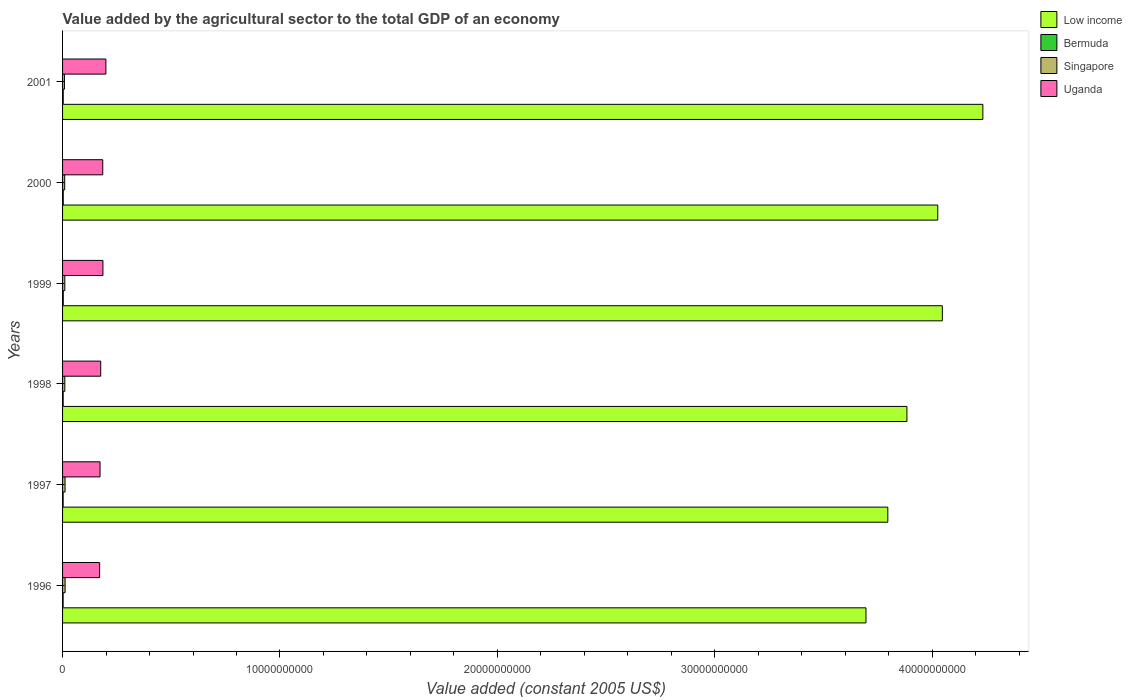Are the number of bars per tick equal to the number of legend labels?
Offer a very short reply. Yes. Are the number of bars on each tick of the Y-axis equal?
Your answer should be compact. Yes. In how many cases, is the number of bars for a given year not equal to the number of legend labels?
Make the answer very short. 0. What is the value added by the agricultural sector in Low income in 1996?
Your response must be concise. 3.70e+1. Across all years, what is the maximum value added by the agricultural sector in Uganda?
Ensure brevity in your answer.  1.99e+09. Across all years, what is the minimum value added by the agricultural sector in Uganda?
Offer a terse response. 1.71e+09. In which year was the value added by the agricultural sector in Singapore minimum?
Your response must be concise. 2001. What is the total value added by the agricultural sector in Bermuda in the graph?
Provide a short and direct response. 1.75e+08. What is the difference between the value added by the agricultural sector in Singapore in 1998 and that in 2000?
Your response must be concise. 5.67e+06. What is the difference between the value added by the agricultural sector in Singapore in 2000 and the value added by the agricultural sector in Low income in 2001?
Offer a very short reply. -4.22e+1. What is the average value added by the agricultural sector in Bermuda per year?
Ensure brevity in your answer.  2.92e+07. In the year 1998, what is the difference between the value added by the agricultural sector in Low income and value added by the agricultural sector in Bermuda?
Make the answer very short. 3.88e+1. What is the ratio of the value added by the agricultural sector in Uganda in 1997 to that in 1998?
Give a very brief answer. 0.98. What is the difference between the highest and the second highest value added by the agricultural sector in Low income?
Keep it short and to the point. 1.86e+09. What is the difference between the highest and the lowest value added by the agricultural sector in Uganda?
Your answer should be very brief. 2.88e+08. Is it the case that in every year, the sum of the value added by the agricultural sector in Singapore and value added by the agricultural sector in Uganda is greater than the sum of value added by the agricultural sector in Low income and value added by the agricultural sector in Bermuda?
Make the answer very short. Yes. What does the 1st bar from the top in 1996 represents?
Ensure brevity in your answer.  Uganda. What does the 3rd bar from the bottom in 1996 represents?
Keep it short and to the point. Singapore. Is it the case that in every year, the sum of the value added by the agricultural sector in Uganda and value added by the agricultural sector in Low income is greater than the value added by the agricultural sector in Singapore?
Provide a succinct answer. Yes. How many bars are there?
Provide a short and direct response. 24. How many years are there in the graph?
Make the answer very short. 6. Does the graph contain any zero values?
Ensure brevity in your answer.  No. How many legend labels are there?
Your answer should be very brief. 4. How are the legend labels stacked?
Provide a short and direct response. Vertical. What is the title of the graph?
Ensure brevity in your answer.  Value added by the agricultural sector to the total GDP of an economy. Does "Tuvalu" appear as one of the legend labels in the graph?
Your answer should be compact. No. What is the label or title of the X-axis?
Keep it short and to the point. Value added (constant 2005 US$). What is the Value added (constant 2005 US$) of Low income in 1996?
Your response must be concise. 3.70e+1. What is the Value added (constant 2005 US$) in Bermuda in 1996?
Your response must be concise. 2.56e+07. What is the Value added (constant 2005 US$) in Singapore in 1996?
Your response must be concise. 1.16e+08. What is the Value added (constant 2005 US$) in Uganda in 1996?
Offer a terse response. 1.71e+09. What is the Value added (constant 2005 US$) of Low income in 1997?
Offer a terse response. 3.80e+1. What is the Value added (constant 2005 US$) in Bermuda in 1997?
Your answer should be compact. 2.68e+07. What is the Value added (constant 2005 US$) in Singapore in 1997?
Make the answer very short. 1.14e+08. What is the Value added (constant 2005 US$) in Uganda in 1997?
Offer a very short reply. 1.72e+09. What is the Value added (constant 2005 US$) in Low income in 1998?
Provide a succinct answer. 3.88e+1. What is the Value added (constant 2005 US$) in Bermuda in 1998?
Your answer should be compact. 2.78e+07. What is the Value added (constant 2005 US$) of Singapore in 1998?
Offer a terse response. 1.04e+08. What is the Value added (constant 2005 US$) in Uganda in 1998?
Offer a very short reply. 1.75e+09. What is the Value added (constant 2005 US$) of Low income in 1999?
Provide a short and direct response. 4.05e+1. What is the Value added (constant 2005 US$) in Bermuda in 1999?
Ensure brevity in your answer.  3.24e+07. What is the Value added (constant 2005 US$) of Singapore in 1999?
Ensure brevity in your answer.  1.04e+08. What is the Value added (constant 2005 US$) of Uganda in 1999?
Your answer should be very brief. 1.86e+09. What is the Value added (constant 2005 US$) of Low income in 2000?
Make the answer very short. 4.03e+1. What is the Value added (constant 2005 US$) in Bermuda in 2000?
Offer a very short reply. 3.15e+07. What is the Value added (constant 2005 US$) in Singapore in 2000?
Ensure brevity in your answer.  9.86e+07. What is the Value added (constant 2005 US$) of Uganda in 2000?
Offer a very short reply. 1.85e+09. What is the Value added (constant 2005 US$) in Low income in 2001?
Offer a terse response. 4.23e+1. What is the Value added (constant 2005 US$) in Bermuda in 2001?
Provide a short and direct response. 3.10e+07. What is the Value added (constant 2005 US$) of Singapore in 2001?
Provide a short and direct response. 8.63e+07. What is the Value added (constant 2005 US$) in Uganda in 2001?
Provide a succinct answer. 1.99e+09. Across all years, what is the maximum Value added (constant 2005 US$) in Low income?
Provide a succinct answer. 4.23e+1. Across all years, what is the maximum Value added (constant 2005 US$) in Bermuda?
Offer a terse response. 3.24e+07. Across all years, what is the maximum Value added (constant 2005 US$) of Singapore?
Your response must be concise. 1.16e+08. Across all years, what is the maximum Value added (constant 2005 US$) in Uganda?
Provide a short and direct response. 1.99e+09. Across all years, what is the minimum Value added (constant 2005 US$) of Low income?
Provide a succinct answer. 3.70e+1. Across all years, what is the minimum Value added (constant 2005 US$) of Bermuda?
Give a very brief answer. 2.56e+07. Across all years, what is the minimum Value added (constant 2005 US$) of Singapore?
Offer a very short reply. 8.63e+07. Across all years, what is the minimum Value added (constant 2005 US$) in Uganda?
Offer a terse response. 1.71e+09. What is the total Value added (constant 2005 US$) in Low income in the graph?
Provide a succinct answer. 2.37e+11. What is the total Value added (constant 2005 US$) of Bermuda in the graph?
Your response must be concise. 1.75e+08. What is the total Value added (constant 2005 US$) in Singapore in the graph?
Ensure brevity in your answer.  6.23e+08. What is the total Value added (constant 2005 US$) in Uganda in the graph?
Make the answer very short. 1.09e+1. What is the difference between the Value added (constant 2005 US$) in Low income in 1996 and that in 1997?
Make the answer very short. -1.00e+09. What is the difference between the Value added (constant 2005 US$) of Bermuda in 1996 and that in 1997?
Your response must be concise. -1.18e+06. What is the difference between the Value added (constant 2005 US$) in Singapore in 1996 and that in 1997?
Make the answer very short. 1.75e+06. What is the difference between the Value added (constant 2005 US$) in Uganda in 1996 and that in 1997?
Make the answer very short. -1.86e+07. What is the difference between the Value added (constant 2005 US$) in Low income in 1996 and that in 1998?
Ensure brevity in your answer.  -1.88e+09. What is the difference between the Value added (constant 2005 US$) of Bermuda in 1996 and that in 1998?
Make the answer very short. -2.22e+06. What is the difference between the Value added (constant 2005 US$) of Singapore in 1996 and that in 1998?
Keep it short and to the point. 1.16e+07. What is the difference between the Value added (constant 2005 US$) of Uganda in 1996 and that in 1998?
Provide a succinct answer. -4.91e+07. What is the difference between the Value added (constant 2005 US$) in Low income in 1996 and that in 1999?
Ensure brevity in your answer.  -3.51e+09. What is the difference between the Value added (constant 2005 US$) of Bermuda in 1996 and that in 1999?
Provide a short and direct response. -6.76e+06. What is the difference between the Value added (constant 2005 US$) in Singapore in 1996 and that in 1999?
Provide a short and direct response. 1.23e+07. What is the difference between the Value added (constant 2005 US$) in Uganda in 1996 and that in 1999?
Your answer should be compact. -1.51e+08. What is the difference between the Value added (constant 2005 US$) in Low income in 1996 and that in 2000?
Provide a short and direct response. -3.30e+09. What is the difference between the Value added (constant 2005 US$) in Bermuda in 1996 and that in 2000?
Your response must be concise. -5.92e+06. What is the difference between the Value added (constant 2005 US$) of Singapore in 1996 and that in 2000?
Your response must be concise. 1.73e+07. What is the difference between the Value added (constant 2005 US$) of Uganda in 1996 and that in 2000?
Offer a terse response. -1.43e+08. What is the difference between the Value added (constant 2005 US$) of Low income in 1996 and that in 2001?
Offer a terse response. -5.38e+09. What is the difference between the Value added (constant 2005 US$) in Bermuda in 1996 and that in 2001?
Your answer should be very brief. -5.35e+06. What is the difference between the Value added (constant 2005 US$) in Singapore in 1996 and that in 2001?
Your answer should be compact. 2.97e+07. What is the difference between the Value added (constant 2005 US$) in Uganda in 1996 and that in 2001?
Your answer should be very brief. -2.88e+08. What is the difference between the Value added (constant 2005 US$) in Low income in 1997 and that in 1998?
Make the answer very short. -8.79e+08. What is the difference between the Value added (constant 2005 US$) in Bermuda in 1997 and that in 1998?
Ensure brevity in your answer.  -1.04e+06. What is the difference between the Value added (constant 2005 US$) in Singapore in 1997 and that in 1998?
Keep it short and to the point. 9.89e+06. What is the difference between the Value added (constant 2005 US$) in Uganda in 1997 and that in 1998?
Offer a terse response. -3.05e+07. What is the difference between the Value added (constant 2005 US$) in Low income in 1997 and that in 1999?
Provide a short and direct response. -2.51e+09. What is the difference between the Value added (constant 2005 US$) of Bermuda in 1997 and that in 1999?
Offer a terse response. -5.58e+06. What is the difference between the Value added (constant 2005 US$) in Singapore in 1997 and that in 1999?
Ensure brevity in your answer.  1.06e+07. What is the difference between the Value added (constant 2005 US$) in Uganda in 1997 and that in 1999?
Ensure brevity in your answer.  -1.33e+08. What is the difference between the Value added (constant 2005 US$) in Low income in 1997 and that in 2000?
Offer a very short reply. -2.30e+09. What is the difference between the Value added (constant 2005 US$) of Bermuda in 1997 and that in 2000?
Make the answer very short. -4.74e+06. What is the difference between the Value added (constant 2005 US$) of Singapore in 1997 and that in 2000?
Provide a succinct answer. 1.56e+07. What is the difference between the Value added (constant 2005 US$) of Uganda in 1997 and that in 2000?
Make the answer very short. -1.25e+08. What is the difference between the Value added (constant 2005 US$) in Low income in 1997 and that in 2001?
Ensure brevity in your answer.  -4.37e+09. What is the difference between the Value added (constant 2005 US$) of Bermuda in 1997 and that in 2001?
Your answer should be compact. -4.17e+06. What is the difference between the Value added (constant 2005 US$) of Singapore in 1997 and that in 2001?
Provide a short and direct response. 2.79e+07. What is the difference between the Value added (constant 2005 US$) of Uganda in 1997 and that in 2001?
Give a very brief answer. -2.70e+08. What is the difference between the Value added (constant 2005 US$) in Low income in 1998 and that in 1999?
Your answer should be compact. -1.63e+09. What is the difference between the Value added (constant 2005 US$) of Bermuda in 1998 and that in 1999?
Your response must be concise. -4.54e+06. What is the difference between the Value added (constant 2005 US$) of Singapore in 1998 and that in 1999?
Your answer should be very brief. 6.63e+05. What is the difference between the Value added (constant 2005 US$) in Uganda in 1998 and that in 1999?
Offer a terse response. -1.02e+08. What is the difference between the Value added (constant 2005 US$) of Low income in 1998 and that in 2000?
Your answer should be very brief. -1.42e+09. What is the difference between the Value added (constant 2005 US$) of Bermuda in 1998 and that in 2000?
Provide a succinct answer. -3.70e+06. What is the difference between the Value added (constant 2005 US$) in Singapore in 1998 and that in 2000?
Ensure brevity in your answer.  5.67e+06. What is the difference between the Value added (constant 2005 US$) in Uganda in 1998 and that in 2000?
Provide a succinct answer. -9.40e+07. What is the difference between the Value added (constant 2005 US$) in Low income in 1998 and that in 2001?
Your answer should be compact. -3.49e+09. What is the difference between the Value added (constant 2005 US$) of Bermuda in 1998 and that in 2001?
Keep it short and to the point. -3.12e+06. What is the difference between the Value added (constant 2005 US$) in Singapore in 1998 and that in 2001?
Your response must be concise. 1.80e+07. What is the difference between the Value added (constant 2005 US$) in Uganda in 1998 and that in 2001?
Provide a short and direct response. -2.39e+08. What is the difference between the Value added (constant 2005 US$) in Low income in 1999 and that in 2000?
Make the answer very short. 2.11e+08. What is the difference between the Value added (constant 2005 US$) of Bermuda in 1999 and that in 2000?
Offer a very short reply. 8.38e+05. What is the difference between the Value added (constant 2005 US$) of Singapore in 1999 and that in 2000?
Give a very brief answer. 5.00e+06. What is the difference between the Value added (constant 2005 US$) of Uganda in 1999 and that in 2000?
Provide a short and direct response. 8.14e+06. What is the difference between the Value added (constant 2005 US$) in Low income in 1999 and that in 2001?
Your answer should be compact. -1.86e+09. What is the difference between the Value added (constant 2005 US$) in Bermuda in 1999 and that in 2001?
Your answer should be compact. 1.42e+06. What is the difference between the Value added (constant 2005 US$) in Singapore in 1999 and that in 2001?
Your answer should be compact. 1.74e+07. What is the difference between the Value added (constant 2005 US$) in Uganda in 1999 and that in 2001?
Your response must be concise. -1.37e+08. What is the difference between the Value added (constant 2005 US$) in Low income in 2000 and that in 2001?
Make the answer very short. -2.07e+09. What is the difference between the Value added (constant 2005 US$) in Bermuda in 2000 and that in 2001?
Make the answer very short. 5.77e+05. What is the difference between the Value added (constant 2005 US$) in Singapore in 2000 and that in 2001?
Your response must be concise. 1.24e+07. What is the difference between the Value added (constant 2005 US$) in Uganda in 2000 and that in 2001?
Give a very brief answer. -1.45e+08. What is the difference between the Value added (constant 2005 US$) in Low income in 1996 and the Value added (constant 2005 US$) in Bermuda in 1997?
Ensure brevity in your answer.  3.69e+1. What is the difference between the Value added (constant 2005 US$) in Low income in 1996 and the Value added (constant 2005 US$) in Singapore in 1997?
Offer a terse response. 3.68e+1. What is the difference between the Value added (constant 2005 US$) in Low income in 1996 and the Value added (constant 2005 US$) in Uganda in 1997?
Offer a terse response. 3.52e+1. What is the difference between the Value added (constant 2005 US$) in Bermuda in 1996 and the Value added (constant 2005 US$) in Singapore in 1997?
Offer a terse response. -8.86e+07. What is the difference between the Value added (constant 2005 US$) of Bermuda in 1996 and the Value added (constant 2005 US$) of Uganda in 1997?
Your answer should be very brief. -1.70e+09. What is the difference between the Value added (constant 2005 US$) in Singapore in 1996 and the Value added (constant 2005 US$) in Uganda in 1997?
Provide a short and direct response. -1.61e+09. What is the difference between the Value added (constant 2005 US$) in Low income in 1996 and the Value added (constant 2005 US$) in Bermuda in 1998?
Give a very brief answer. 3.69e+1. What is the difference between the Value added (constant 2005 US$) of Low income in 1996 and the Value added (constant 2005 US$) of Singapore in 1998?
Your response must be concise. 3.68e+1. What is the difference between the Value added (constant 2005 US$) in Low income in 1996 and the Value added (constant 2005 US$) in Uganda in 1998?
Give a very brief answer. 3.52e+1. What is the difference between the Value added (constant 2005 US$) in Bermuda in 1996 and the Value added (constant 2005 US$) in Singapore in 1998?
Keep it short and to the point. -7.87e+07. What is the difference between the Value added (constant 2005 US$) of Bermuda in 1996 and the Value added (constant 2005 US$) of Uganda in 1998?
Offer a terse response. -1.73e+09. What is the difference between the Value added (constant 2005 US$) of Singapore in 1996 and the Value added (constant 2005 US$) of Uganda in 1998?
Give a very brief answer. -1.64e+09. What is the difference between the Value added (constant 2005 US$) of Low income in 1996 and the Value added (constant 2005 US$) of Bermuda in 1999?
Keep it short and to the point. 3.69e+1. What is the difference between the Value added (constant 2005 US$) of Low income in 1996 and the Value added (constant 2005 US$) of Singapore in 1999?
Make the answer very short. 3.68e+1. What is the difference between the Value added (constant 2005 US$) of Low income in 1996 and the Value added (constant 2005 US$) of Uganda in 1999?
Ensure brevity in your answer.  3.51e+1. What is the difference between the Value added (constant 2005 US$) of Bermuda in 1996 and the Value added (constant 2005 US$) of Singapore in 1999?
Provide a succinct answer. -7.80e+07. What is the difference between the Value added (constant 2005 US$) of Bermuda in 1996 and the Value added (constant 2005 US$) of Uganda in 1999?
Your answer should be very brief. -1.83e+09. What is the difference between the Value added (constant 2005 US$) in Singapore in 1996 and the Value added (constant 2005 US$) in Uganda in 1999?
Provide a succinct answer. -1.74e+09. What is the difference between the Value added (constant 2005 US$) in Low income in 1996 and the Value added (constant 2005 US$) in Bermuda in 2000?
Ensure brevity in your answer.  3.69e+1. What is the difference between the Value added (constant 2005 US$) of Low income in 1996 and the Value added (constant 2005 US$) of Singapore in 2000?
Make the answer very short. 3.69e+1. What is the difference between the Value added (constant 2005 US$) of Low income in 1996 and the Value added (constant 2005 US$) of Uganda in 2000?
Your response must be concise. 3.51e+1. What is the difference between the Value added (constant 2005 US$) of Bermuda in 1996 and the Value added (constant 2005 US$) of Singapore in 2000?
Ensure brevity in your answer.  -7.30e+07. What is the difference between the Value added (constant 2005 US$) in Bermuda in 1996 and the Value added (constant 2005 US$) in Uganda in 2000?
Your response must be concise. -1.82e+09. What is the difference between the Value added (constant 2005 US$) in Singapore in 1996 and the Value added (constant 2005 US$) in Uganda in 2000?
Your response must be concise. -1.73e+09. What is the difference between the Value added (constant 2005 US$) in Low income in 1996 and the Value added (constant 2005 US$) in Bermuda in 2001?
Give a very brief answer. 3.69e+1. What is the difference between the Value added (constant 2005 US$) of Low income in 1996 and the Value added (constant 2005 US$) of Singapore in 2001?
Give a very brief answer. 3.69e+1. What is the difference between the Value added (constant 2005 US$) in Low income in 1996 and the Value added (constant 2005 US$) in Uganda in 2001?
Your response must be concise. 3.50e+1. What is the difference between the Value added (constant 2005 US$) in Bermuda in 1996 and the Value added (constant 2005 US$) in Singapore in 2001?
Make the answer very short. -6.07e+07. What is the difference between the Value added (constant 2005 US$) in Bermuda in 1996 and the Value added (constant 2005 US$) in Uganda in 2001?
Provide a short and direct response. -1.97e+09. What is the difference between the Value added (constant 2005 US$) of Singapore in 1996 and the Value added (constant 2005 US$) of Uganda in 2001?
Give a very brief answer. -1.88e+09. What is the difference between the Value added (constant 2005 US$) in Low income in 1997 and the Value added (constant 2005 US$) in Bermuda in 1998?
Your response must be concise. 3.79e+1. What is the difference between the Value added (constant 2005 US$) in Low income in 1997 and the Value added (constant 2005 US$) in Singapore in 1998?
Offer a terse response. 3.79e+1. What is the difference between the Value added (constant 2005 US$) in Low income in 1997 and the Value added (constant 2005 US$) in Uganda in 1998?
Provide a succinct answer. 3.62e+1. What is the difference between the Value added (constant 2005 US$) in Bermuda in 1997 and the Value added (constant 2005 US$) in Singapore in 1998?
Your answer should be compact. -7.75e+07. What is the difference between the Value added (constant 2005 US$) of Bermuda in 1997 and the Value added (constant 2005 US$) of Uganda in 1998?
Keep it short and to the point. -1.73e+09. What is the difference between the Value added (constant 2005 US$) of Singapore in 1997 and the Value added (constant 2005 US$) of Uganda in 1998?
Give a very brief answer. -1.64e+09. What is the difference between the Value added (constant 2005 US$) of Low income in 1997 and the Value added (constant 2005 US$) of Bermuda in 1999?
Offer a very short reply. 3.79e+1. What is the difference between the Value added (constant 2005 US$) of Low income in 1997 and the Value added (constant 2005 US$) of Singapore in 1999?
Your answer should be compact. 3.79e+1. What is the difference between the Value added (constant 2005 US$) of Low income in 1997 and the Value added (constant 2005 US$) of Uganda in 1999?
Offer a terse response. 3.61e+1. What is the difference between the Value added (constant 2005 US$) of Bermuda in 1997 and the Value added (constant 2005 US$) of Singapore in 1999?
Your response must be concise. -7.68e+07. What is the difference between the Value added (constant 2005 US$) of Bermuda in 1997 and the Value added (constant 2005 US$) of Uganda in 1999?
Offer a terse response. -1.83e+09. What is the difference between the Value added (constant 2005 US$) in Singapore in 1997 and the Value added (constant 2005 US$) in Uganda in 1999?
Make the answer very short. -1.74e+09. What is the difference between the Value added (constant 2005 US$) of Low income in 1997 and the Value added (constant 2005 US$) of Bermuda in 2000?
Provide a succinct answer. 3.79e+1. What is the difference between the Value added (constant 2005 US$) in Low income in 1997 and the Value added (constant 2005 US$) in Singapore in 2000?
Keep it short and to the point. 3.79e+1. What is the difference between the Value added (constant 2005 US$) of Low income in 1997 and the Value added (constant 2005 US$) of Uganda in 2000?
Offer a very short reply. 3.61e+1. What is the difference between the Value added (constant 2005 US$) of Bermuda in 1997 and the Value added (constant 2005 US$) of Singapore in 2000?
Offer a terse response. -7.18e+07. What is the difference between the Value added (constant 2005 US$) in Bermuda in 1997 and the Value added (constant 2005 US$) in Uganda in 2000?
Ensure brevity in your answer.  -1.82e+09. What is the difference between the Value added (constant 2005 US$) in Singapore in 1997 and the Value added (constant 2005 US$) in Uganda in 2000?
Your answer should be compact. -1.73e+09. What is the difference between the Value added (constant 2005 US$) of Low income in 1997 and the Value added (constant 2005 US$) of Bermuda in 2001?
Your answer should be very brief. 3.79e+1. What is the difference between the Value added (constant 2005 US$) in Low income in 1997 and the Value added (constant 2005 US$) in Singapore in 2001?
Provide a short and direct response. 3.79e+1. What is the difference between the Value added (constant 2005 US$) in Low income in 1997 and the Value added (constant 2005 US$) in Uganda in 2001?
Offer a very short reply. 3.60e+1. What is the difference between the Value added (constant 2005 US$) of Bermuda in 1997 and the Value added (constant 2005 US$) of Singapore in 2001?
Offer a very short reply. -5.95e+07. What is the difference between the Value added (constant 2005 US$) of Bermuda in 1997 and the Value added (constant 2005 US$) of Uganda in 2001?
Keep it short and to the point. -1.97e+09. What is the difference between the Value added (constant 2005 US$) of Singapore in 1997 and the Value added (constant 2005 US$) of Uganda in 2001?
Provide a succinct answer. -1.88e+09. What is the difference between the Value added (constant 2005 US$) of Low income in 1998 and the Value added (constant 2005 US$) of Bermuda in 1999?
Keep it short and to the point. 3.88e+1. What is the difference between the Value added (constant 2005 US$) in Low income in 1998 and the Value added (constant 2005 US$) in Singapore in 1999?
Give a very brief answer. 3.87e+1. What is the difference between the Value added (constant 2005 US$) in Low income in 1998 and the Value added (constant 2005 US$) in Uganda in 1999?
Make the answer very short. 3.70e+1. What is the difference between the Value added (constant 2005 US$) in Bermuda in 1998 and the Value added (constant 2005 US$) in Singapore in 1999?
Provide a short and direct response. -7.58e+07. What is the difference between the Value added (constant 2005 US$) of Bermuda in 1998 and the Value added (constant 2005 US$) of Uganda in 1999?
Provide a short and direct response. -1.83e+09. What is the difference between the Value added (constant 2005 US$) of Singapore in 1998 and the Value added (constant 2005 US$) of Uganda in 1999?
Offer a very short reply. -1.75e+09. What is the difference between the Value added (constant 2005 US$) in Low income in 1998 and the Value added (constant 2005 US$) in Bermuda in 2000?
Make the answer very short. 3.88e+1. What is the difference between the Value added (constant 2005 US$) of Low income in 1998 and the Value added (constant 2005 US$) of Singapore in 2000?
Offer a terse response. 3.87e+1. What is the difference between the Value added (constant 2005 US$) in Low income in 1998 and the Value added (constant 2005 US$) in Uganda in 2000?
Give a very brief answer. 3.70e+1. What is the difference between the Value added (constant 2005 US$) of Bermuda in 1998 and the Value added (constant 2005 US$) of Singapore in 2000?
Keep it short and to the point. -7.08e+07. What is the difference between the Value added (constant 2005 US$) in Bermuda in 1998 and the Value added (constant 2005 US$) in Uganda in 2000?
Provide a succinct answer. -1.82e+09. What is the difference between the Value added (constant 2005 US$) of Singapore in 1998 and the Value added (constant 2005 US$) of Uganda in 2000?
Ensure brevity in your answer.  -1.74e+09. What is the difference between the Value added (constant 2005 US$) in Low income in 1998 and the Value added (constant 2005 US$) in Bermuda in 2001?
Make the answer very short. 3.88e+1. What is the difference between the Value added (constant 2005 US$) in Low income in 1998 and the Value added (constant 2005 US$) in Singapore in 2001?
Offer a very short reply. 3.87e+1. What is the difference between the Value added (constant 2005 US$) in Low income in 1998 and the Value added (constant 2005 US$) in Uganda in 2001?
Give a very brief answer. 3.68e+1. What is the difference between the Value added (constant 2005 US$) of Bermuda in 1998 and the Value added (constant 2005 US$) of Singapore in 2001?
Your answer should be very brief. -5.84e+07. What is the difference between the Value added (constant 2005 US$) in Bermuda in 1998 and the Value added (constant 2005 US$) in Uganda in 2001?
Provide a succinct answer. -1.97e+09. What is the difference between the Value added (constant 2005 US$) of Singapore in 1998 and the Value added (constant 2005 US$) of Uganda in 2001?
Provide a short and direct response. -1.89e+09. What is the difference between the Value added (constant 2005 US$) in Low income in 1999 and the Value added (constant 2005 US$) in Bermuda in 2000?
Your response must be concise. 4.04e+1. What is the difference between the Value added (constant 2005 US$) in Low income in 1999 and the Value added (constant 2005 US$) in Singapore in 2000?
Provide a succinct answer. 4.04e+1. What is the difference between the Value added (constant 2005 US$) in Low income in 1999 and the Value added (constant 2005 US$) in Uganda in 2000?
Ensure brevity in your answer.  3.86e+1. What is the difference between the Value added (constant 2005 US$) in Bermuda in 1999 and the Value added (constant 2005 US$) in Singapore in 2000?
Give a very brief answer. -6.63e+07. What is the difference between the Value added (constant 2005 US$) in Bermuda in 1999 and the Value added (constant 2005 US$) in Uganda in 2000?
Offer a terse response. -1.82e+09. What is the difference between the Value added (constant 2005 US$) in Singapore in 1999 and the Value added (constant 2005 US$) in Uganda in 2000?
Your answer should be very brief. -1.74e+09. What is the difference between the Value added (constant 2005 US$) of Low income in 1999 and the Value added (constant 2005 US$) of Bermuda in 2001?
Provide a succinct answer. 4.04e+1. What is the difference between the Value added (constant 2005 US$) of Low income in 1999 and the Value added (constant 2005 US$) of Singapore in 2001?
Keep it short and to the point. 4.04e+1. What is the difference between the Value added (constant 2005 US$) in Low income in 1999 and the Value added (constant 2005 US$) in Uganda in 2001?
Offer a very short reply. 3.85e+1. What is the difference between the Value added (constant 2005 US$) in Bermuda in 1999 and the Value added (constant 2005 US$) in Singapore in 2001?
Your response must be concise. -5.39e+07. What is the difference between the Value added (constant 2005 US$) in Bermuda in 1999 and the Value added (constant 2005 US$) in Uganda in 2001?
Make the answer very short. -1.96e+09. What is the difference between the Value added (constant 2005 US$) of Singapore in 1999 and the Value added (constant 2005 US$) of Uganda in 2001?
Offer a terse response. -1.89e+09. What is the difference between the Value added (constant 2005 US$) of Low income in 2000 and the Value added (constant 2005 US$) of Bermuda in 2001?
Ensure brevity in your answer.  4.02e+1. What is the difference between the Value added (constant 2005 US$) in Low income in 2000 and the Value added (constant 2005 US$) in Singapore in 2001?
Provide a short and direct response. 4.02e+1. What is the difference between the Value added (constant 2005 US$) of Low income in 2000 and the Value added (constant 2005 US$) of Uganda in 2001?
Give a very brief answer. 3.83e+1. What is the difference between the Value added (constant 2005 US$) of Bermuda in 2000 and the Value added (constant 2005 US$) of Singapore in 2001?
Your answer should be compact. -5.47e+07. What is the difference between the Value added (constant 2005 US$) of Bermuda in 2000 and the Value added (constant 2005 US$) of Uganda in 2001?
Make the answer very short. -1.96e+09. What is the difference between the Value added (constant 2005 US$) in Singapore in 2000 and the Value added (constant 2005 US$) in Uganda in 2001?
Your answer should be compact. -1.89e+09. What is the average Value added (constant 2005 US$) of Low income per year?
Your answer should be very brief. 3.95e+1. What is the average Value added (constant 2005 US$) of Bermuda per year?
Offer a very short reply. 2.92e+07. What is the average Value added (constant 2005 US$) in Singapore per year?
Provide a short and direct response. 1.04e+08. What is the average Value added (constant 2005 US$) in Uganda per year?
Offer a very short reply. 1.81e+09. In the year 1996, what is the difference between the Value added (constant 2005 US$) of Low income and Value added (constant 2005 US$) of Bermuda?
Make the answer very short. 3.69e+1. In the year 1996, what is the difference between the Value added (constant 2005 US$) in Low income and Value added (constant 2005 US$) in Singapore?
Ensure brevity in your answer.  3.68e+1. In the year 1996, what is the difference between the Value added (constant 2005 US$) in Low income and Value added (constant 2005 US$) in Uganda?
Offer a very short reply. 3.52e+1. In the year 1996, what is the difference between the Value added (constant 2005 US$) of Bermuda and Value added (constant 2005 US$) of Singapore?
Your answer should be very brief. -9.03e+07. In the year 1996, what is the difference between the Value added (constant 2005 US$) in Bermuda and Value added (constant 2005 US$) in Uganda?
Offer a terse response. -1.68e+09. In the year 1996, what is the difference between the Value added (constant 2005 US$) of Singapore and Value added (constant 2005 US$) of Uganda?
Keep it short and to the point. -1.59e+09. In the year 1997, what is the difference between the Value added (constant 2005 US$) of Low income and Value added (constant 2005 US$) of Bermuda?
Your response must be concise. 3.79e+1. In the year 1997, what is the difference between the Value added (constant 2005 US$) of Low income and Value added (constant 2005 US$) of Singapore?
Give a very brief answer. 3.78e+1. In the year 1997, what is the difference between the Value added (constant 2005 US$) in Low income and Value added (constant 2005 US$) in Uganda?
Your answer should be very brief. 3.62e+1. In the year 1997, what is the difference between the Value added (constant 2005 US$) in Bermuda and Value added (constant 2005 US$) in Singapore?
Keep it short and to the point. -8.74e+07. In the year 1997, what is the difference between the Value added (constant 2005 US$) of Bermuda and Value added (constant 2005 US$) of Uganda?
Offer a very short reply. -1.70e+09. In the year 1997, what is the difference between the Value added (constant 2005 US$) of Singapore and Value added (constant 2005 US$) of Uganda?
Provide a short and direct response. -1.61e+09. In the year 1998, what is the difference between the Value added (constant 2005 US$) of Low income and Value added (constant 2005 US$) of Bermuda?
Offer a terse response. 3.88e+1. In the year 1998, what is the difference between the Value added (constant 2005 US$) in Low income and Value added (constant 2005 US$) in Singapore?
Make the answer very short. 3.87e+1. In the year 1998, what is the difference between the Value added (constant 2005 US$) in Low income and Value added (constant 2005 US$) in Uganda?
Offer a very short reply. 3.71e+1. In the year 1998, what is the difference between the Value added (constant 2005 US$) in Bermuda and Value added (constant 2005 US$) in Singapore?
Ensure brevity in your answer.  -7.65e+07. In the year 1998, what is the difference between the Value added (constant 2005 US$) in Bermuda and Value added (constant 2005 US$) in Uganda?
Provide a succinct answer. -1.73e+09. In the year 1998, what is the difference between the Value added (constant 2005 US$) in Singapore and Value added (constant 2005 US$) in Uganda?
Offer a very short reply. -1.65e+09. In the year 1999, what is the difference between the Value added (constant 2005 US$) of Low income and Value added (constant 2005 US$) of Bermuda?
Your response must be concise. 4.04e+1. In the year 1999, what is the difference between the Value added (constant 2005 US$) of Low income and Value added (constant 2005 US$) of Singapore?
Make the answer very short. 4.04e+1. In the year 1999, what is the difference between the Value added (constant 2005 US$) in Low income and Value added (constant 2005 US$) in Uganda?
Your response must be concise. 3.86e+1. In the year 1999, what is the difference between the Value added (constant 2005 US$) in Bermuda and Value added (constant 2005 US$) in Singapore?
Offer a terse response. -7.13e+07. In the year 1999, what is the difference between the Value added (constant 2005 US$) in Bermuda and Value added (constant 2005 US$) in Uganda?
Make the answer very short. -1.82e+09. In the year 1999, what is the difference between the Value added (constant 2005 US$) of Singapore and Value added (constant 2005 US$) of Uganda?
Provide a succinct answer. -1.75e+09. In the year 2000, what is the difference between the Value added (constant 2005 US$) in Low income and Value added (constant 2005 US$) in Bermuda?
Your response must be concise. 4.02e+1. In the year 2000, what is the difference between the Value added (constant 2005 US$) of Low income and Value added (constant 2005 US$) of Singapore?
Offer a terse response. 4.02e+1. In the year 2000, what is the difference between the Value added (constant 2005 US$) of Low income and Value added (constant 2005 US$) of Uganda?
Provide a short and direct response. 3.84e+1. In the year 2000, what is the difference between the Value added (constant 2005 US$) in Bermuda and Value added (constant 2005 US$) in Singapore?
Give a very brief answer. -6.71e+07. In the year 2000, what is the difference between the Value added (constant 2005 US$) of Bermuda and Value added (constant 2005 US$) of Uganda?
Your response must be concise. -1.82e+09. In the year 2000, what is the difference between the Value added (constant 2005 US$) of Singapore and Value added (constant 2005 US$) of Uganda?
Make the answer very short. -1.75e+09. In the year 2001, what is the difference between the Value added (constant 2005 US$) in Low income and Value added (constant 2005 US$) in Bermuda?
Provide a succinct answer. 4.23e+1. In the year 2001, what is the difference between the Value added (constant 2005 US$) in Low income and Value added (constant 2005 US$) in Singapore?
Give a very brief answer. 4.22e+1. In the year 2001, what is the difference between the Value added (constant 2005 US$) in Low income and Value added (constant 2005 US$) in Uganda?
Ensure brevity in your answer.  4.03e+1. In the year 2001, what is the difference between the Value added (constant 2005 US$) in Bermuda and Value added (constant 2005 US$) in Singapore?
Your answer should be compact. -5.53e+07. In the year 2001, what is the difference between the Value added (constant 2005 US$) in Bermuda and Value added (constant 2005 US$) in Uganda?
Your answer should be compact. -1.96e+09. In the year 2001, what is the difference between the Value added (constant 2005 US$) in Singapore and Value added (constant 2005 US$) in Uganda?
Your answer should be very brief. -1.91e+09. What is the ratio of the Value added (constant 2005 US$) in Low income in 1996 to that in 1997?
Your answer should be compact. 0.97. What is the ratio of the Value added (constant 2005 US$) of Bermuda in 1996 to that in 1997?
Give a very brief answer. 0.96. What is the ratio of the Value added (constant 2005 US$) in Singapore in 1996 to that in 1997?
Your answer should be very brief. 1.02. What is the ratio of the Value added (constant 2005 US$) of Uganda in 1996 to that in 1997?
Ensure brevity in your answer.  0.99. What is the ratio of the Value added (constant 2005 US$) in Low income in 1996 to that in 1998?
Your response must be concise. 0.95. What is the ratio of the Value added (constant 2005 US$) of Bermuda in 1996 to that in 1998?
Give a very brief answer. 0.92. What is the ratio of the Value added (constant 2005 US$) in Singapore in 1996 to that in 1998?
Offer a very short reply. 1.11. What is the ratio of the Value added (constant 2005 US$) of Low income in 1996 to that in 1999?
Offer a very short reply. 0.91. What is the ratio of the Value added (constant 2005 US$) in Bermuda in 1996 to that in 1999?
Offer a very short reply. 0.79. What is the ratio of the Value added (constant 2005 US$) in Singapore in 1996 to that in 1999?
Keep it short and to the point. 1.12. What is the ratio of the Value added (constant 2005 US$) of Uganda in 1996 to that in 1999?
Provide a short and direct response. 0.92. What is the ratio of the Value added (constant 2005 US$) in Low income in 1996 to that in 2000?
Your answer should be compact. 0.92. What is the ratio of the Value added (constant 2005 US$) of Bermuda in 1996 to that in 2000?
Your response must be concise. 0.81. What is the ratio of the Value added (constant 2005 US$) in Singapore in 1996 to that in 2000?
Your answer should be very brief. 1.18. What is the ratio of the Value added (constant 2005 US$) of Uganda in 1996 to that in 2000?
Offer a terse response. 0.92. What is the ratio of the Value added (constant 2005 US$) of Low income in 1996 to that in 2001?
Your answer should be very brief. 0.87. What is the ratio of the Value added (constant 2005 US$) in Bermuda in 1996 to that in 2001?
Your answer should be compact. 0.83. What is the ratio of the Value added (constant 2005 US$) of Singapore in 1996 to that in 2001?
Offer a very short reply. 1.34. What is the ratio of the Value added (constant 2005 US$) of Uganda in 1996 to that in 2001?
Your answer should be very brief. 0.86. What is the ratio of the Value added (constant 2005 US$) in Low income in 1997 to that in 1998?
Your answer should be compact. 0.98. What is the ratio of the Value added (constant 2005 US$) in Bermuda in 1997 to that in 1998?
Give a very brief answer. 0.96. What is the ratio of the Value added (constant 2005 US$) of Singapore in 1997 to that in 1998?
Ensure brevity in your answer.  1.09. What is the ratio of the Value added (constant 2005 US$) in Uganda in 1997 to that in 1998?
Your answer should be compact. 0.98. What is the ratio of the Value added (constant 2005 US$) of Low income in 1997 to that in 1999?
Provide a short and direct response. 0.94. What is the ratio of the Value added (constant 2005 US$) in Bermuda in 1997 to that in 1999?
Your answer should be very brief. 0.83. What is the ratio of the Value added (constant 2005 US$) of Singapore in 1997 to that in 1999?
Your response must be concise. 1.1. What is the ratio of the Value added (constant 2005 US$) in Uganda in 1997 to that in 1999?
Your answer should be very brief. 0.93. What is the ratio of the Value added (constant 2005 US$) in Low income in 1997 to that in 2000?
Your answer should be very brief. 0.94. What is the ratio of the Value added (constant 2005 US$) in Bermuda in 1997 to that in 2000?
Offer a terse response. 0.85. What is the ratio of the Value added (constant 2005 US$) in Singapore in 1997 to that in 2000?
Ensure brevity in your answer.  1.16. What is the ratio of the Value added (constant 2005 US$) of Uganda in 1997 to that in 2000?
Offer a terse response. 0.93. What is the ratio of the Value added (constant 2005 US$) in Low income in 1997 to that in 2001?
Ensure brevity in your answer.  0.9. What is the ratio of the Value added (constant 2005 US$) of Bermuda in 1997 to that in 2001?
Offer a very short reply. 0.87. What is the ratio of the Value added (constant 2005 US$) of Singapore in 1997 to that in 2001?
Your answer should be very brief. 1.32. What is the ratio of the Value added (constant 2005 US$) in Uganda in 1997 to that in 2001?
Give a very brief answer. 0.86. What is the ratio of the Value added (constant 2005 US$) in Low income in 1998 to that in 1999?
Your response must be concise. 0.96. What is the ratio of the Value added (constant 2005 US$) of Bermuda in 1998 to that in 1999?
Your response must be concise. 0.86. What is the ratio of the Value added (constant 2005 US$) in Singapore in 1998 to that in 1999?
Give a very brief answer. 1.01. What is the ratio of the Value added (constant 2005 US$) in Uganda in 1998 to that in 1999?
Your answer should be compact. 0.94. What is the ratio of the Value added (constant 2005 US$) in Low income in 1998 to that in 2000?
Provide a succinct answer. 0.96. What is the ratio of the Value added (constant 2005 US$) of Bermuda in 1998 to that in 2000?
Keep it short and to the point. 0.88. What is the ratio of the Value added (constant 2005 US$) in Singapore in 1998 to that in 2000?
Provide a succinct answer. 1.06. What is the ratio of the Value added (constant 2005 US$) in Uganda in 1998 to that in 2000?
Make the answer very short. 0.95. What is the ratio of the Value added (constant 2005 US$) in Low income in 1998 to that in 2001?
Ensure brevity in your answer.  0.92. What is the ratio of the Value added (constant 2005 US$) of Bermuda in 1998 to that in 2001?
Provide a succinct answer. 0.9. What is the ratio of the Value added (constant 2005 US$) in Singapore in 1998 to that in 2001?
Offer a terse response. 1.21. What is the ratio of the Value added (constant 2005 US$) of Uganda in 1998 to that in 2001?
Provide a succinct answer. 0.88. What is the ratio of the Value added (constant 2005 US$) of Low income in 1999 to that in 2000?
Offer a terse response. 1.01. What is the ratio of the Value added (constant 2005 US$) of Bermuda in 1999 to that in 2000?
Ensure brevity in your answer.  1.03. What is the ratio of the Value added (constant 2005 US$) of Singapore in 1999 to that in 2000?
Provide a succinct answer. 1.05. What is the ratio of the Value added (constant 2005 US$) of Low income in 1999 to that in 2001?
Provide a short and direct response. 0.96. What is the ratio of the Value added (constant 2005 US$) of Bermuda in 1999 to that in 2001?
Offer a terse response. 1.05. What is the ratio of the Value added (constant 2005 US$) of Singapore in 1999 to that in 2001?
Your answer should be compact. 1.2. What is the ratio of the Value added (constant 2005 US$) of Uganda in 1999 to that in 2001?
Make the answer very short. 0.93. What is the ratio of the Value added (constant 2005 US$) of Low income in 2000 to that in 2001?
Make the answer very short. 0.95. What is the ratio of the Value added (constant 2005 US$) of Bermuda in 2000 to that in 2001?
Your answer should be very brief. 1.02. What is the ratio of the Value added (constant 2005 US$) of Singapore in 2000 to that in 2001?
Ensure brevity in your answer.  1.14. What is the ratio of the Value added (constant 2005 US$) in Uganda in 2000 to that in 2001?
Make the answer very short. 0.93. What is the difference between the highest and the second highest Value added (constant 2005 US$) of Low income?
Give a very brief answer. 1.86e+09. What is the difference between the highest and the second highest Value added (constant 2005 US$) in Bermuda?
Offer a very short reply. 8.38e+05. What is the difference between the highest and the second highest Value added (constant 2005 US$) of Singapore?
Offer a very short reply. 1.75e+06. What is the difference between the highest and the second highest Value added (constant 2005 US$) of Uganda?
Your answer should be very brief. 1.37e+08. What is the difference between the highest and the lowest Value added (constant 2005 US$) of Low income?
Offer a terse response. 5.38e+09. What is the difference between the highest and the lowest Value added (constant 2005 US$) in Bermuda?
Offer a very short reply. 6.76e+06. What is the difference between the highest and the lowest Value added (constant 2005 US$) in Singapore?
Make the answer very short. 2.97e+07. What is the difference between the highest and the lowest Value added (constant 2005 US$) of Uganda?
Your response must be concise. 2.88e+08. 